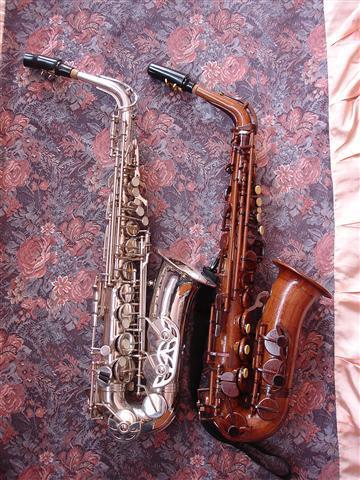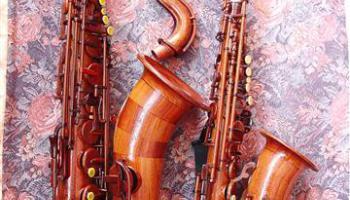The first image is the image on the left, the second image is the image on the right. For the images displayed, is the sentence "At least one image contains multiple saxophones." factually correct? Answer yes or no. Yes. 